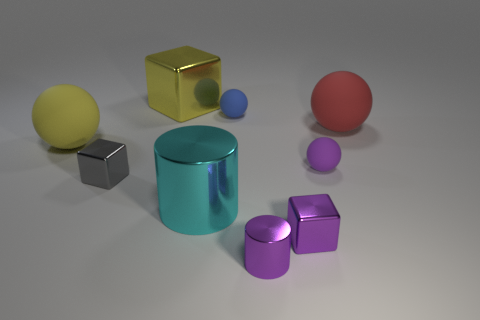Does the large matte object on the right side of the tiny purple shiny block have the same color as the big metallic cube? no 